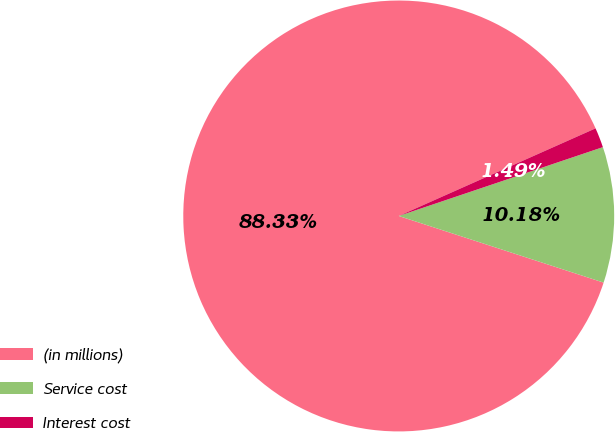<chart> <loc_0><loc_0><loc_500><loc_500><pie_chart><fcel>(in millions)<fcel>Service cost<fcel>Interest cost<nl><fcel>88.33%<fcel>10.18%<fcel>1.49%<nl></chart> 